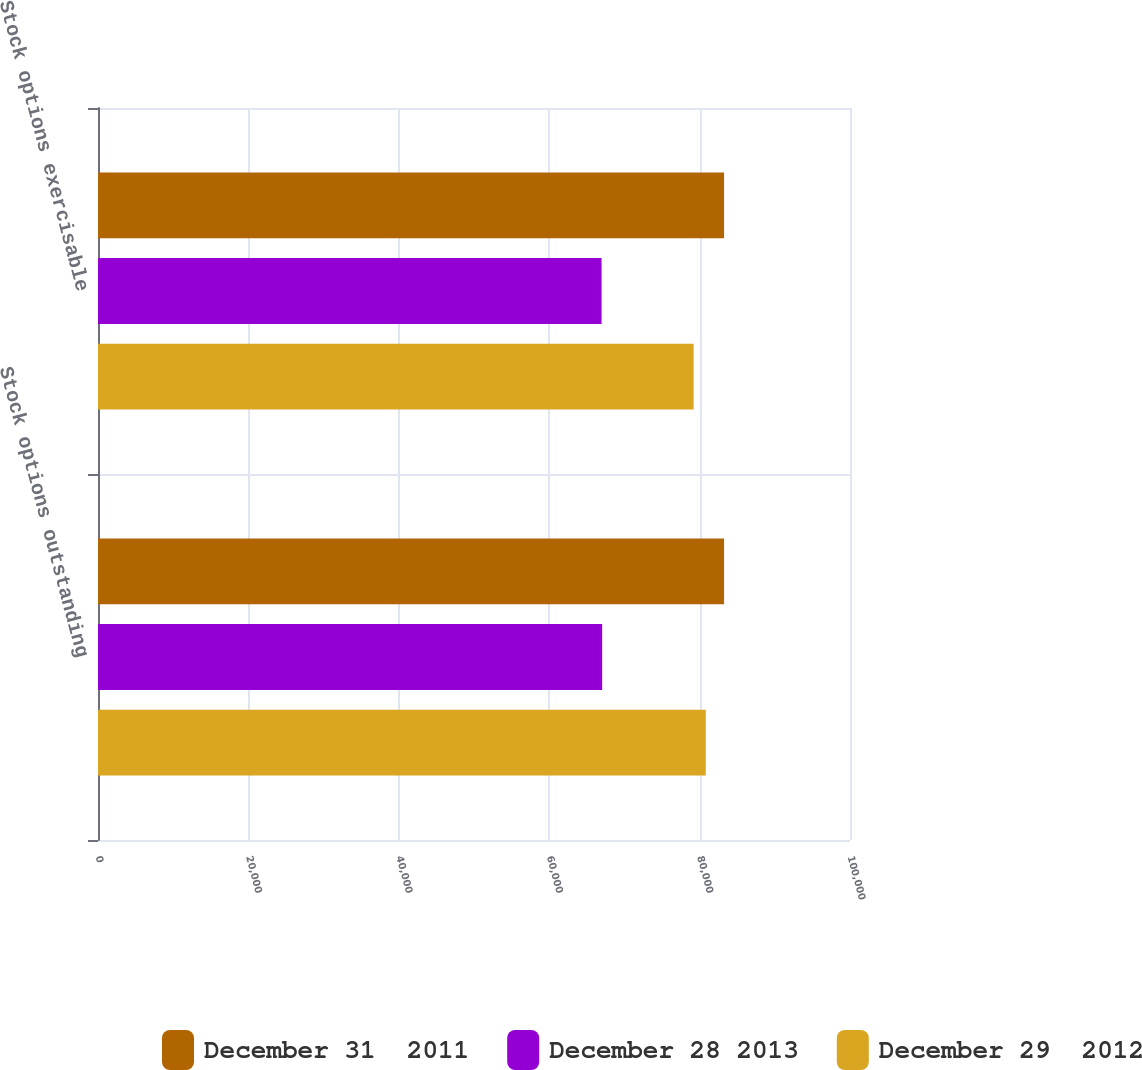Convert chart to OTSL. <chart><loc_0><loc_0><loc_500><loc_500><stacked_bar_chart><ecel><fcel>Stock options outstanding<fcel>Stock options exercisable<nl><fcel>December 31  2011<fcel>83252<fcel>83252<nl><fcel>December 28 2013<fcel>67044<fcel>66964<nl><fcel>December 29  2012<fcel>80821<fcel>79202<nl></chart> 